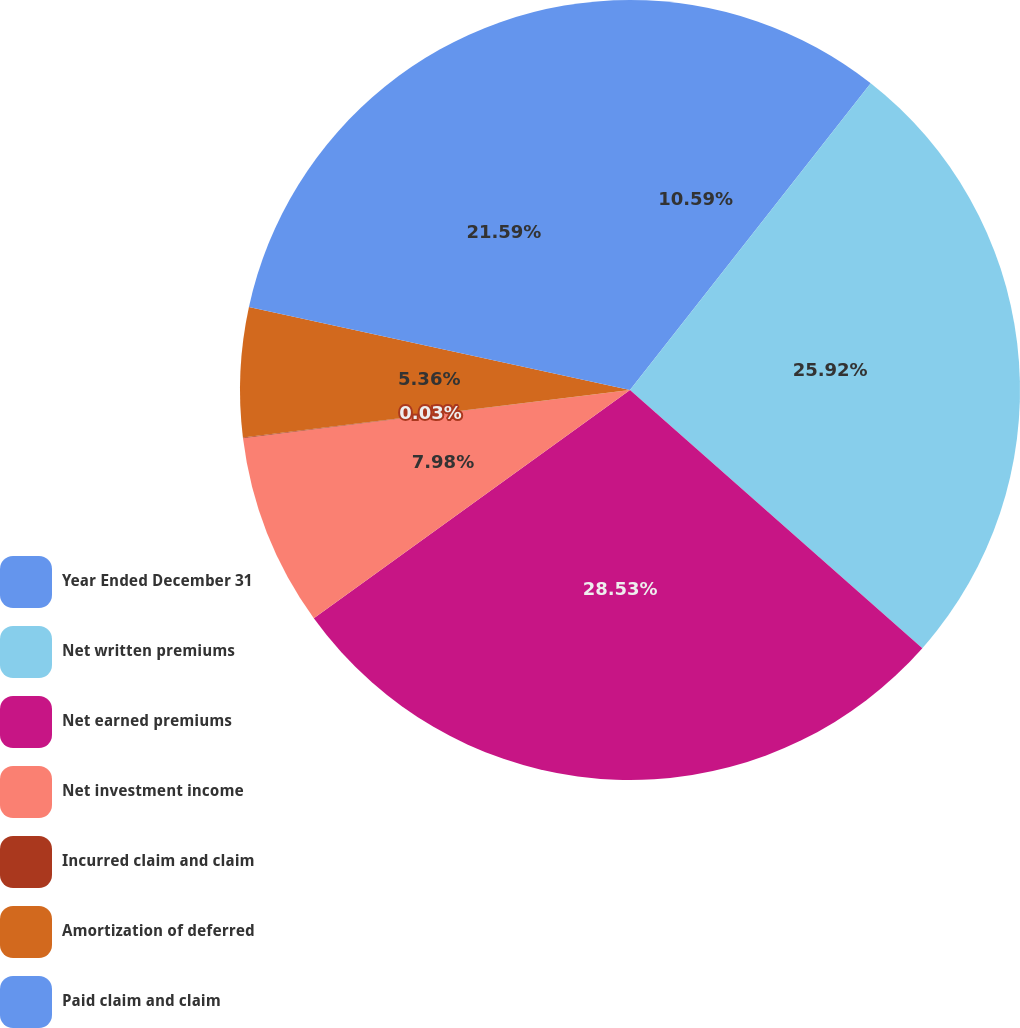Convert chart to OTSL. <chart><loc_0><loc_0><loc_500><loc_500><pie_chart><fcel>Year Ended December 31<fcel>Net written premiums<fcel>Net earned premiums<fcel>Net investment income<fcel>Incurred claim and claim<fcel>Amortization of deferred<fcel>Paid claim and claim<nl><fcel>10.59%<fcel>25.93%<fcel>28.54%<fcel>7.98%<fcel>0.03%<fcel>5.36%<fcel>21.59%<nl></chart> 